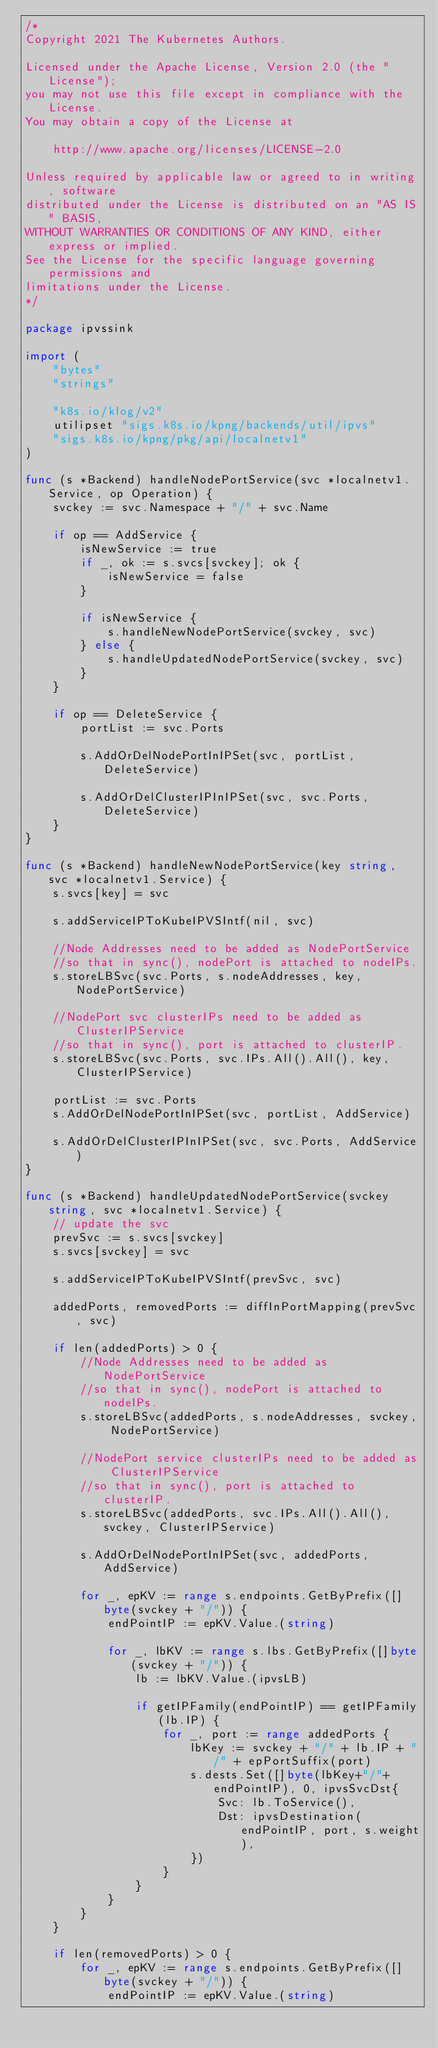Convert code to text. <code><loc_0><loc_0><loc_500><loc_500><_Go_>/*
Copyright 2021 The Kubernetes Authors.

Licensed under the Apache License, Version 2.0 (the "License");
you may not use this file except in compliance with the License.
You may obtain a copy of the License at

    http://www.apache.org/licenses/LICENSE-2.0

Unless required by applicable law or agreed to in writing, software
distributed under the License is distributed on an "AS IS" BASIS,
WITHOUT WARRANTIES OR CONDITIONS OF ANY KIND, either express or implied.
See the License for the specific language governing permissions and
limitations under the License.
*/

package ipvssink

import (
	"bytes"
	"strings"

	"k8s.io/klog/v2"
	utilipset "sigs.k8s.io/kpng/backends/util/ipvs"
	"sigs.k8s.io/kpng/pkg/api/localnetv1"
)

func (s *Backend) handleNodePortService(svc *localnetv1.Service, op Operation) {
	svckey := svc.Namespace + "/" + svc.Name

	if op == AddService {
		isNewService := true
		if _, ok := s.svcs[svckey]; ok {
			isNewService = false
		}

		if isNewService {
			s.handleNewNodePortService(svckey, svc)
		} else {
			s.handleUpdatedNodePortService(svckey, svc)
		}
	}

	if op == DeleteService {
		portList := svc.Ports

		s.AddOrDelNodePortInIPSet(svc, portList, DeleteService)

		s.AddOrDelClusterIPInIPSet(svc, svc.Ports, DeleteService)
	}
}

func (s *Backend) handleNewNodePortService(key string, svc *localnetv1.Service) {
	s.svcs[key] = svc

	s.addServiceIPToKubeIPVSIntf(nil, svc)

	//Node Addresses need to be added as NodePortService
	//so that in sync(), nodePort is attached to nodeIPs.
	s.storeLBSvc(svc.Ports, s.nodeAddresses, key, NodePortService)

	//NodePort svc clusterIPs need to be added as ClusterIPService
	//so that in sync(), port is attached to clusterIP.
	s.storeLBSvc(svc.Ports, svc.IPs.All().All(), key, ClusterIPService)

	portList := svc.Ports
	s.AddOrDelNodePortInIPSet(svc, portList, AddService)

	s.AddOrDelClusterIPInIPSet(svc, svc.Ports, AddService)
}

func (s *Backend) handleUpdatedNodePortService(svckey string, svc *localnetv1.Service) {
	// update the svc
	prevSvc := s.svcs[svckey]
	s.svcs[svckey] = svc

	s.addServiceIPToKubeIPVSIntf(prevSvc, svc)

	addedPorts, removedPorts := diffInPortMapping(prevSvc, svc)

	if len(addedPorts) > 0 {
		//Node Addresses need to be added as NodePortService
		//so that in sync(), nodePort is attached to nodeIPs.
		s.storeLBSvc(addedPorts, s.nodeAddresses, svckey, NodePortService)

		//NodePort service clusterIPs need to be added as ClusterIPService
		//so that in sync(), port is attached to clusterIP.
		s.storeLBSvc(addedPorts, svc.IPs.All().All(), svckey, ClusterIPService)

		s.AddOrDelNodePortInIPSet(svc, addedPorts, AddService)

		for _, epKV := range s.endpoints.GetByPrefix([]byte(svckey + "/")) {
			endPointIP := epKV.Value.(string)

			for _, lbKV := range s.lbs.GetByPrefix([]byte(svckey + "/")) {
				lb := lbKV.Value.(ipvsLB)

				if getIPFamily(endPointIP) == getIPFamily(lb.IP) {
					for _, port := range addedPorts {
						lbKey := svckey + "/" + lb.IP + "/" + epPortSuffix(port)
						s.dests.Set([]byte(lbKey+"/"+endPointIP), 0, ipvsSvcDst{
							Svc: lb.ToService(),
							Dst: ipvsDestination(endPointIP, port, s.weight),
						})
					}
				}
			}
		}
	}

	if len(removedPorts) > 0 {
		for _, epKV := range s.endpoints.GetByPrefix([]byte(svckey + "/")) {
			endPointIP := epKV.Value.(string)
</code> 